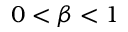Convert formula to latex. <formula><loc_0><loc_0><loc_500><loc_500>0 < \beta < 1</formula> 